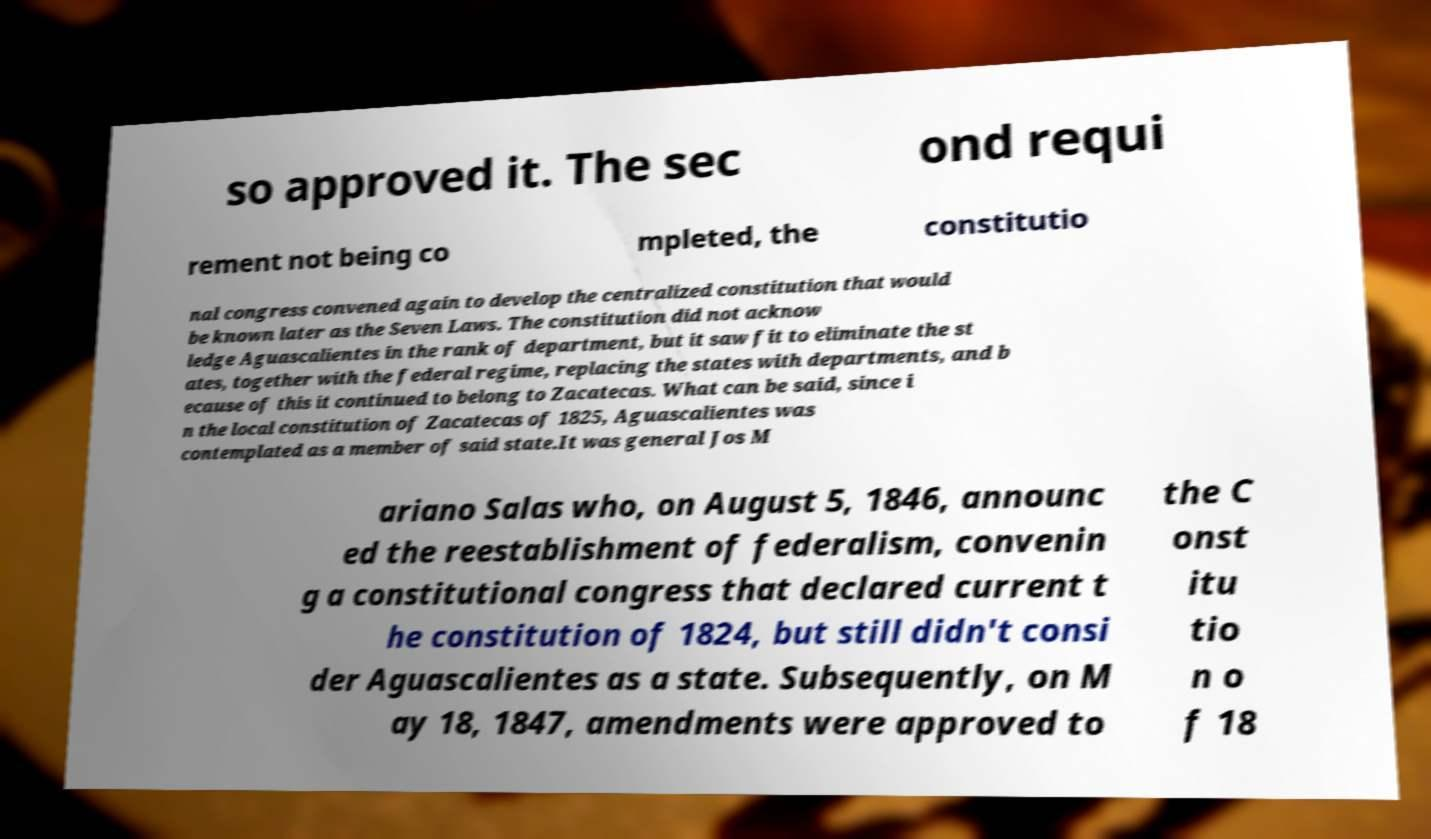Can you read and provide the text displayed in the image?This photo seems to have some interesting text. Can you extract and type it out for me? so approved it. The sec ond requi rement not being co mpleted, the constitutio nal congress convened again to develop the centralized constitution that would be known later as the Seven Laws. The constitution did not acknow ledge Aguascalientes in the rank of department, but it saw fit to eliminate the st ates, together with the federal regime, replacing the states with departments, and b ecause of this it continued to belong to Zacatecas. What can be said, since i n the local constitution of Zacatecas of 1825, Aguascalientes was contemplated as a member of said state.It was general Jos M ariano Salas who, on August 5, 1846, announc ed the reestablishment of federalism, convenin g a constitutional congress that declared current t he constitution of 1824, but still didn't consi der Aguascalientes as a state. Subsequently, on M ay 18, 1847, amendments were approved to the C onst itu tio n o f 18 